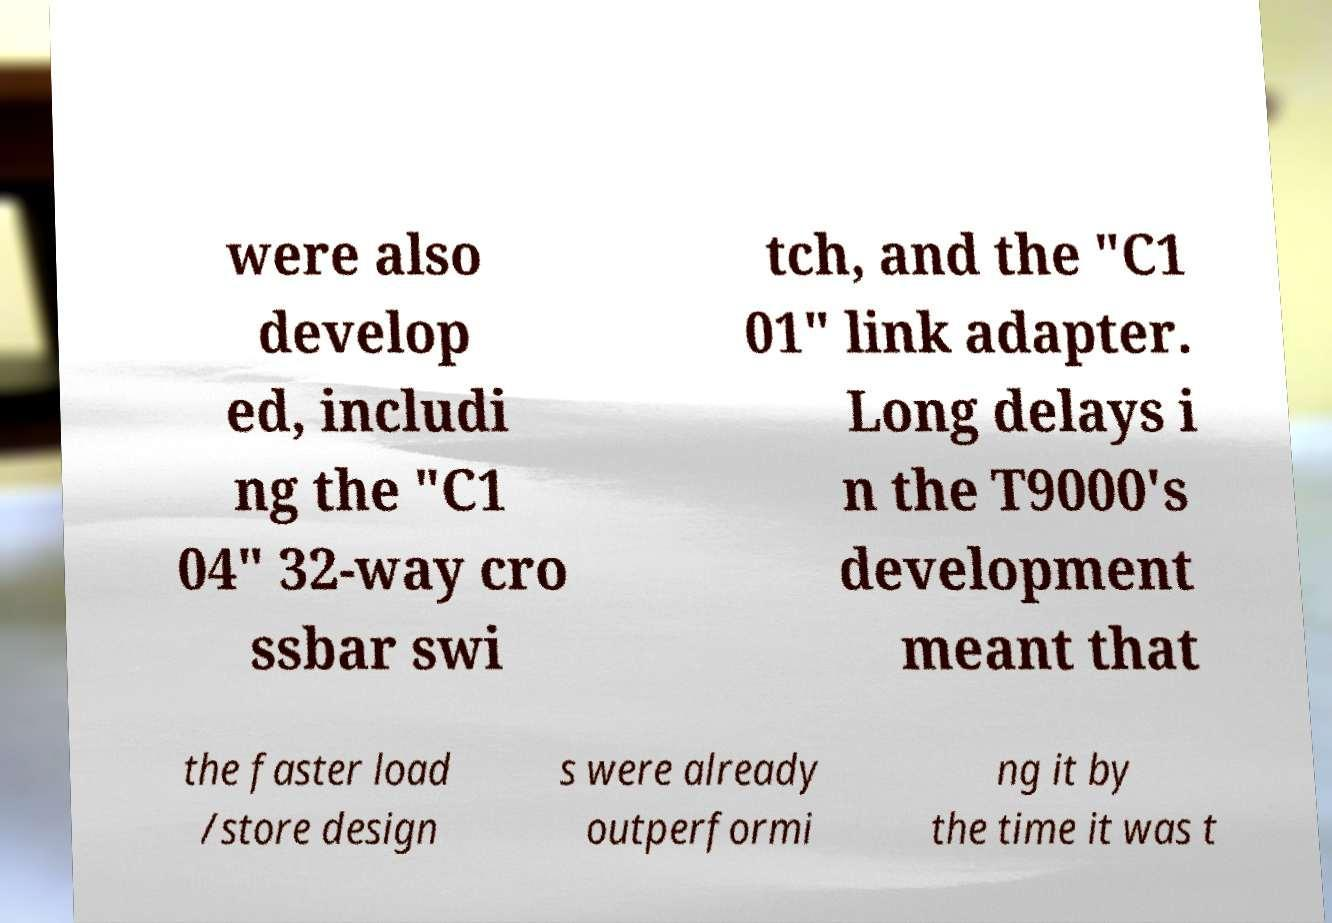For documentation purposes, I need the text within this image transcribed. Could you provide that? were also develop ed, includi ng the "C1 04" 32-way cro ssbar swi tch, and the "C1 01" link adapter. Long delays i n the T9000's development meant that the faster load /store design s were already outperformi ng it by the time it was t 